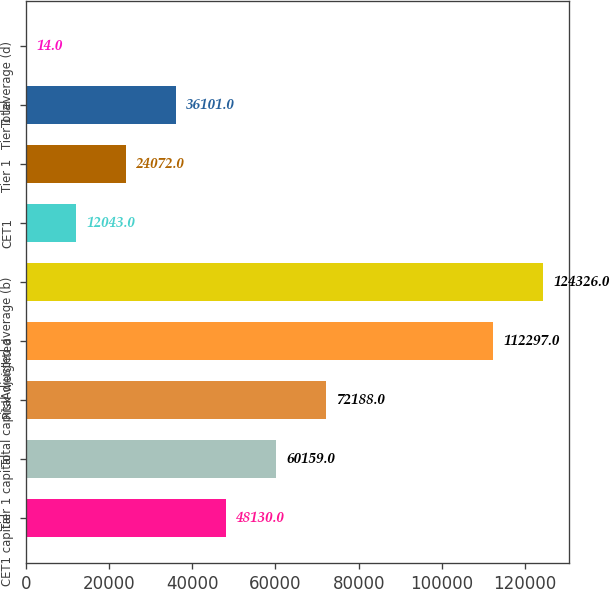<chart> <loc_0><loc_0><loc_500><loc_500><bar_chart><fcel>CET1 capital<fcel>Tier 1 capital<fcel>Total capital<fcel>Risk-weighted<fcel>Adjusted average (b)<fcel>CET1<fcel>Tier 1<fcel>Total<fcel>Tier 1 leverage (d)<nl><fcel>48130<fcel>60159<fcel>72188<fcel>112297<fcel>124326<fcel>12043<fcel>24072<fcel>36101<fcel>14<nl></chart> 